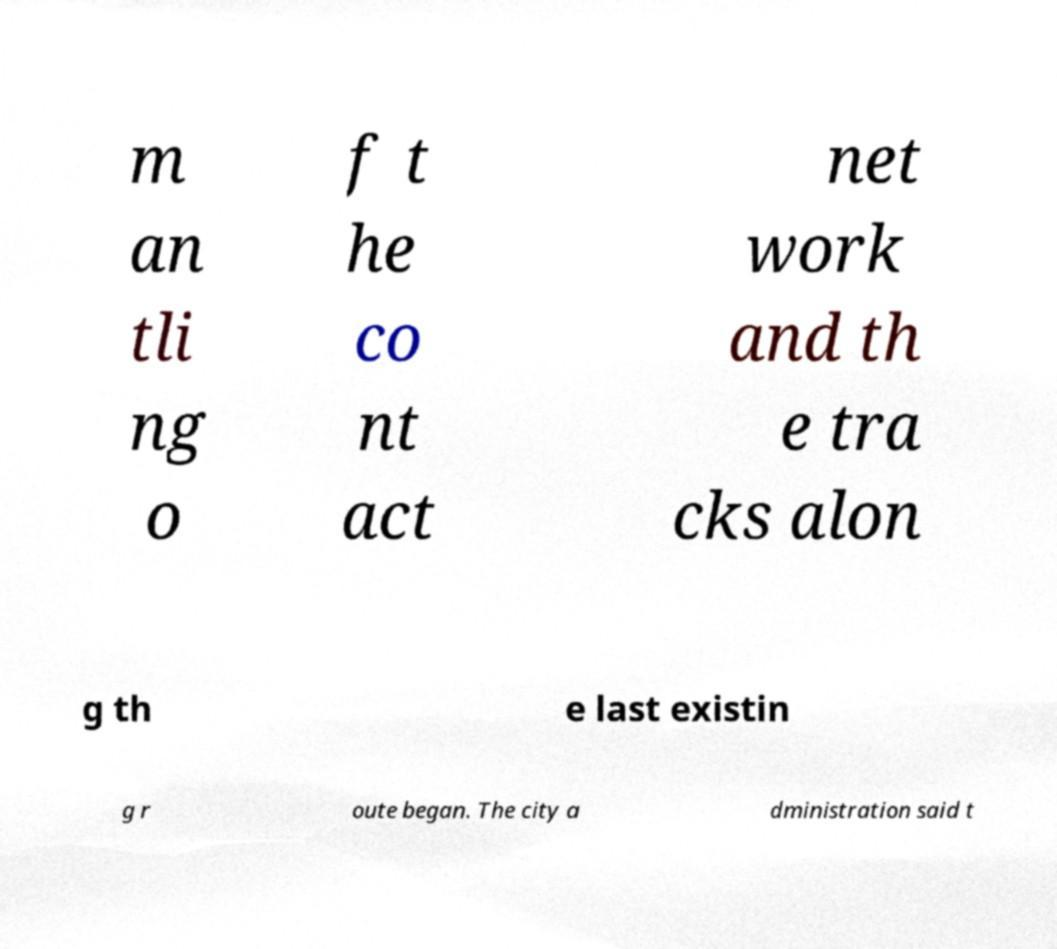For documentation purposes, I need the text within this image transcribed. Could you provide that? m an tli ng o f t he co nt act net work and th e tra cks alon g th e last existin g r oute began. The city a dministration said t 